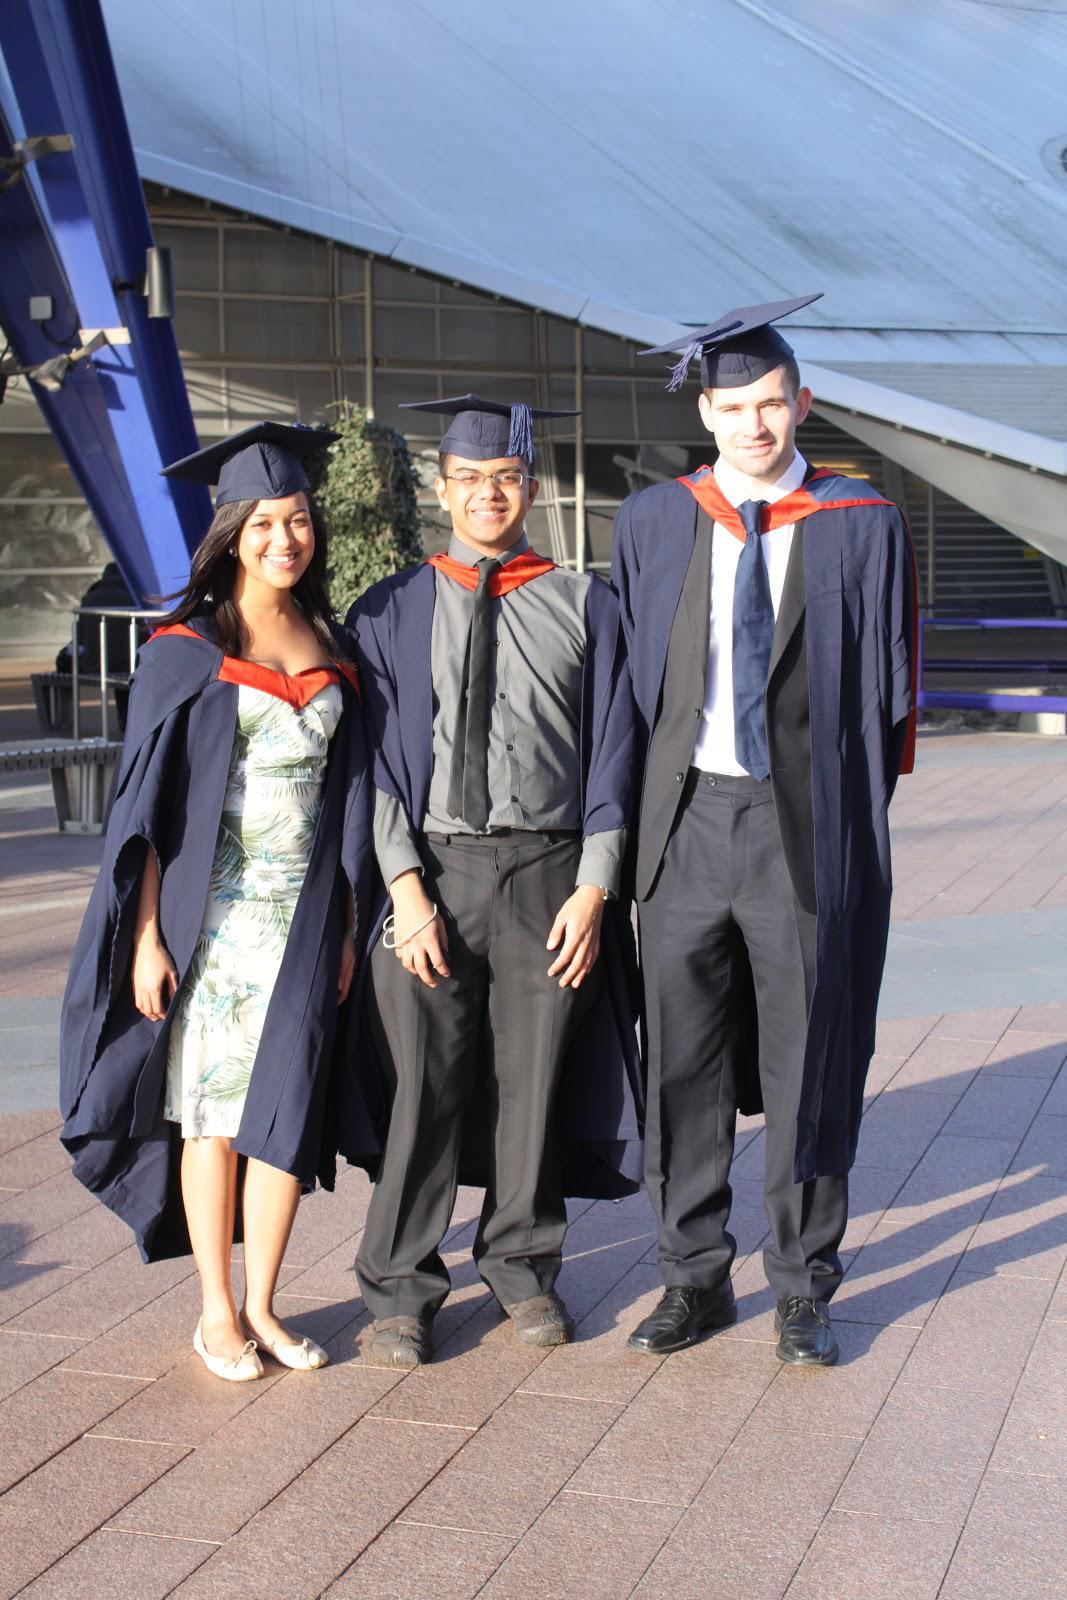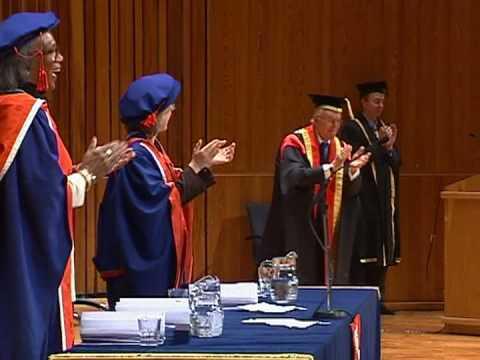The first image is the image on the left, the second image is the image on the right. For the images displayed, is the sentence "There are four graduates in one of the images." factually correct? Answer yes or no. No. The first image is the image on the left, the second image is the image on the right. Considering the images on both sides, is "One image shows a single row of standing, camera-facing graduates numbering no more than four, and the other image includes at least some standing graduates who are not facing forward." valid? Answer yes or no. Yes. 